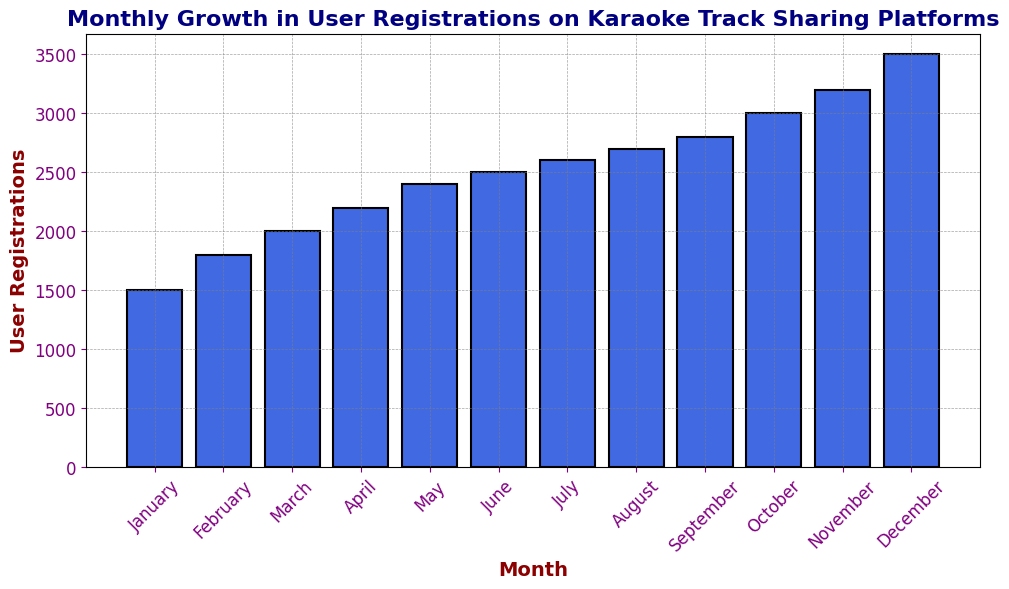what is the total number of user registrations in Q1 (January to March)? To find the total number of registrations in Q1, sum the registrations for January, February, and March. January has 1500, February has 1800, and March has 2000 registrations. So, the total is 1500 + 1800 + 2000 = 5300.
Answer: 5300 Which month had the highest number of user registrations? Observing the bar chart, the tallest bar represents the month with the highest number of registrations. December's bar is the tallest.
Answer: December How many months had user registrations exceeding 2500? Identify the months where the height of the bars exceeds the level marked for 2500. These months are June, July, August, September, October, November, and December.
Answer: 7 What's the average monthly user registration for the months from June to December? Sum the registration numbers from June to December and divide by the number of these months. The registrations are: 2500 + 2600 + 2700 + 2800 + 3000 + 3200 + 3500 = 20300. The average is 20300 / 7 ≈ 2900.
Answer: 2900 Calculate the percentage increase in user registrations from January to December. First, find the difference in registrations between December and January. It is 3500 - 1500 = 2000. Then, calculate the percentage increase using the formula (difference / January registrations) * 100 = (2000 / 1500) * 100 ≈ 133.33%.
Answer: 133.33% What is the difference in user registrations between the month with the highest registrations and the month with the lowest? December has the highest with 3500, and January has the lowest with 1500. The difference is 3500 - 1500 = 2000.
Answer: 2000 Which month had fewer user registrations, April or May? Comparing the height of the bars for April and May, April's bar corresponds to 2200 and May's bar to 2400. April had fewer registrations.
Answer: April What's the combined user registration figure for March and April? Add the registrations for March and April. March has 2000, and April has 2200, so 2000 + 2200 = 4200.
Answer: 4200 